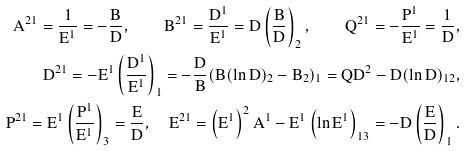<formula> <loc_0><loc_0><loc_500><loc_500>A ^ { 2 1 } = { \frac { 1 } { E ^ { 1 } } } = - { \frac { B } { D } } , \quad B ^ { 2 1 } = { \frac { D ^ { 1 } } { E ^ { 1 } } } = D \left ( { \frac { B } { D } } \right ) _ { 2 } , \quad Q ^ { 2 1 } = - { \frac { P ^ { 1 } } { E ^ { 1 } } } = { \frac { 1 } { D } } , \\ D ^ { 2 1 } = - E ^ { 1 } \left ( { \frac { D ^ { 1 } } { E ^ { 1 } } } \right ) _ { 1 } = - { \frac { D } { B } } ( B ( \ln D ) _ { 2 } - B _ { 2 } ) _ { 1 } = Q D ^ { 2 } - D ( \ln D ) _ { 1 2 } , \\ P ^ { 2 1 } = E ^ { 1 } \left ( { \frac { P ^ { 1 } } { E ^ { 1 } } } \right ) _ { 3 } = { \frac { E } { D } } , \quad E ^ { 2 1 } = \left ( E ^ { 1 } \right ) ^ { 2 } A ^ { 1 } - E ^ { 1 } \left ( \ln E ^ { 1 } \right ) _ { 1 3 } = - D \left ( { \frac { E } { D } } \right ) _ { 1 } .</formula> 